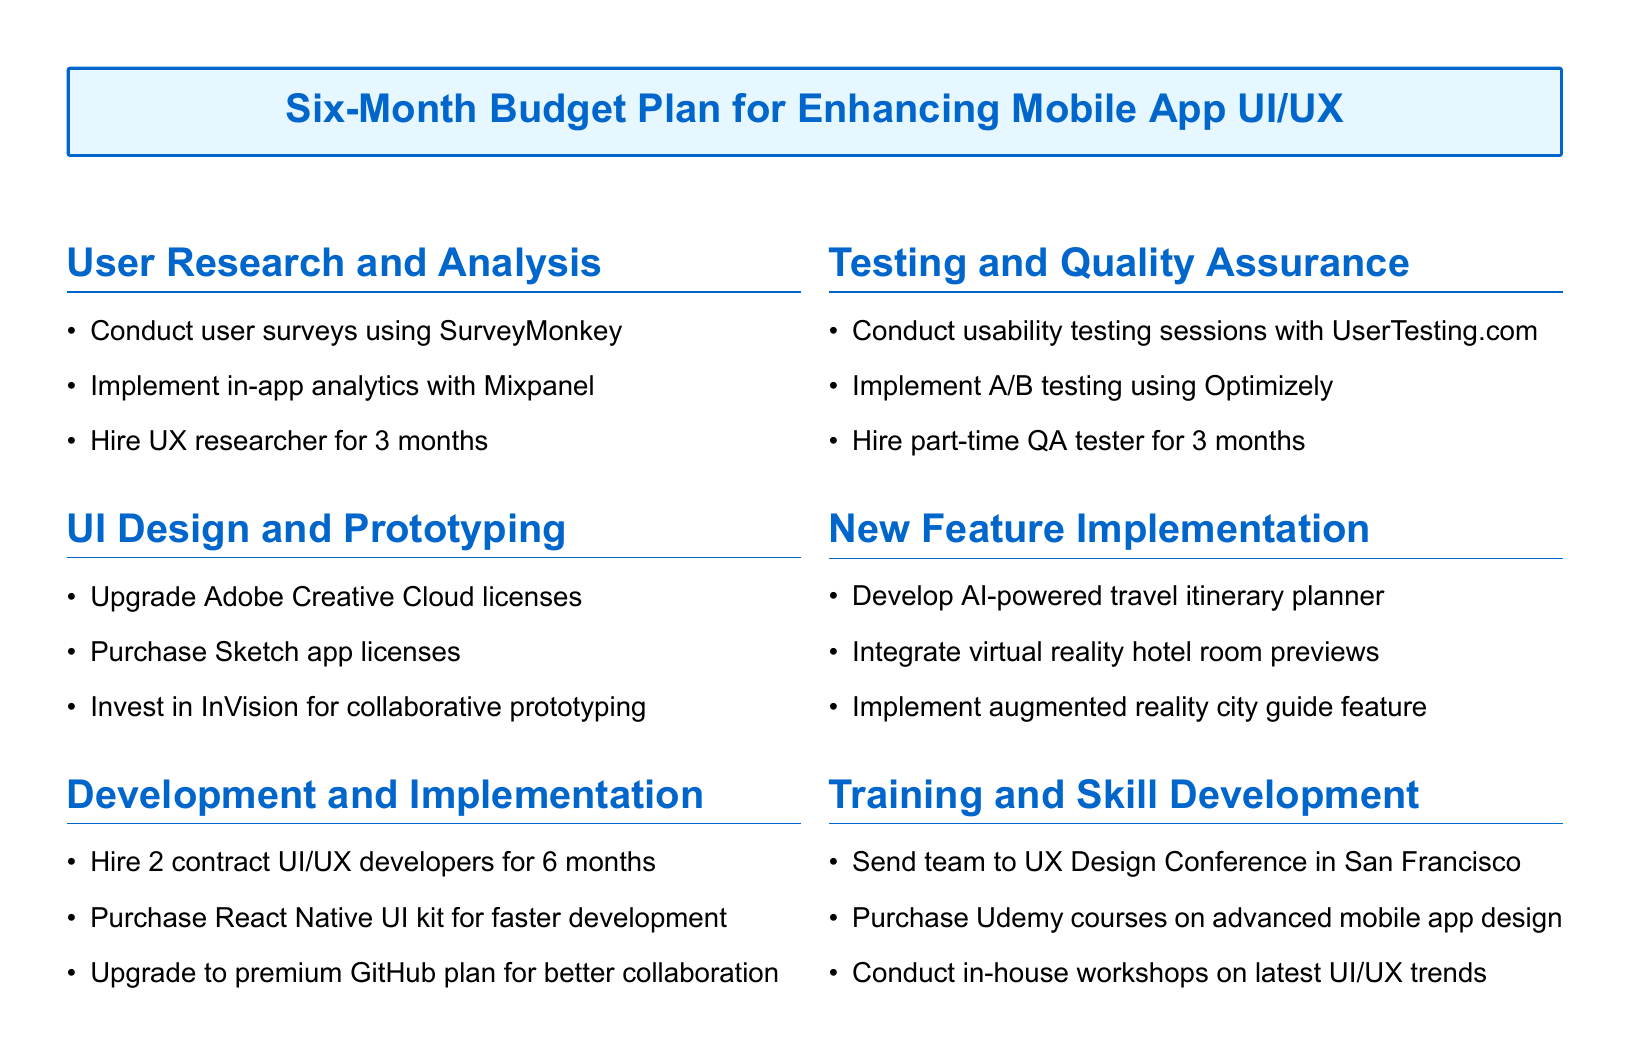What is the total duration for hiring the UX researcher? The document states that the UX researcher will be hired for 3 months.
Answer: 3 months How many contract UI/UX developers will be hired? The budget plan mentions hiring 2 contract UI/UX developers.
Answer: 2 What tool is suggested for conducting usability testing sessions? The document suggests using UserTesting.com for usability testing sessions.
Answer: UserTesting.com Which cloud service is recommended for collaborative prototyping? The document recommends investing in InVision for collaborative prototyping.
Answer: InVision What is one of the new features being implemented? The document lists developing an AI-powered travel itinerary planner as a new feature.
Answer: AI-powered travel itinerary planner How long is the training team expected to attend the UX Design Conference? The document does not specify a duration but mentions the cost associated with sending the team to the conference.
Answer: Not specified Which license will be upgraded for UI design? The budget plan states upgrading Adobe Creative Cloud licenses.
Answer: Adobe Creative Cloud What is one method for A/B testing mentioned in the document? The document mentions implementing A/B testing using Optimizely.
Answer: Optimizely What type of courses will be purchased for skill development? The document states that Udemy courses on advanced mobile app design will be purchased.
Answer: Advanced mobile app design courses 